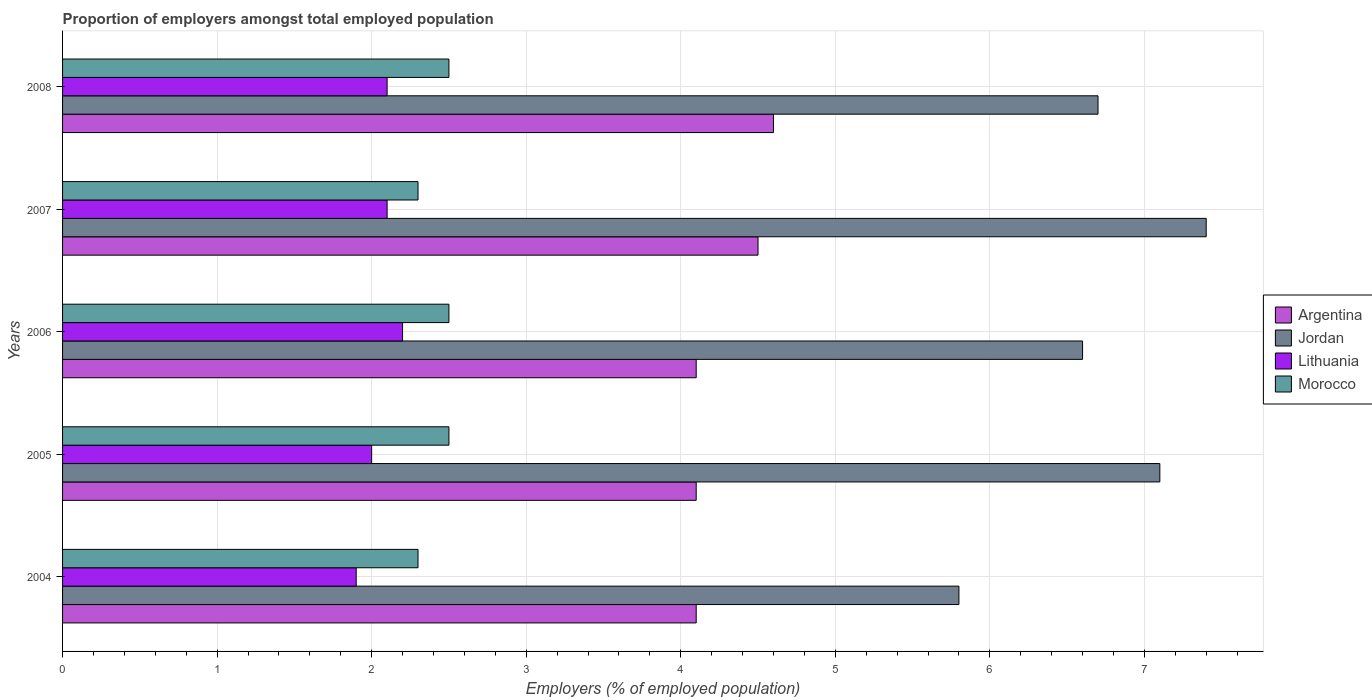How many groups of bars are there?
Offer a very short reply. 5. Are the number of bars on each tick of the Y-axis equal?
Provide a succinct answer. Yes. How many bars are there on the 2nd tick from the top?
Provide a short and direct response. 4. How many bars are there on the 2nd tick from the bottom?
Keep it short and to the point. 4. What is the label of the 2nd group of bars from the top?
Your response must be concise. 2007. In how many cases, is the number of bars for a given year not equal to the number of legend labels?
Offer a very short reply. 0. What is the proportion of employers in Lithuania in 2004?
Make the answer very short. 1.9. Across all years, what is the maximum proportion of employers in Lithuania?
Keep it short and to the point. 2.2. Across all years, what is the minimum proportion of employers in Jordan?
Give a very brief answer. 5.8. In which year was the proportion of employers in Argentina maximum?
Ensure brevity in your answer.  2008. In which year was the proportion of employers in Jordan minimum?
Make the answer very short. 2004. What is the total proportion of employers in Jordan in the graph?
Provide a short and direct response. 33.6. What is the difference between the proportion of employers in Morocco in 2007 and that in 2008?
Your answer should be very brief. -0.2. What is the difference between the proportion of employers in Argentina in 2006 and the proportion of employers in Morocco in 2005?
Provide a short and direct response. 1.6. What is the average proportion of employers in Jordan per year?
Your answer should be very brief. 6.72. In the year 2008, what is the difference between the proportion of employers in Lithuania and proportion of employers in Morocco?
Offer a terse response. -0.4. What is the ratio of the proportion of employers in Morocco in 2004 to that in 2005?
Your answer should be very brief. 0.92. Is the proportion of employers in Lithuania in 2004 less than that in 2008?
Make the answer very short. Yes. Is the difference between the proportion of employers in Lithuania in 2006 and 2008 greater than the difference between the proportion of employers in Morocco in 2006 and 2008?
Provide a short and direct response. Yes. What is the difference between the highest and the second highest proportion of employers in Jordan?
Provide a succinct answer. 0.3. What is the difference between the highest and the lowest proportion of employers in Jordan?
Offer a very short reply. 1.6. Is the sum of the proportion of employers in Jordan in 2004 and 2005 greater than the maximum proportion of employers in Argentina across all years?
Make the answer very short. Yes. What does the 3rd bar from the top in 2006 represents?
Make the answer very short. Jordan. What does the 2nd bar from the bottom in 2004 represents?
Make the answer very short. Jordan. Is it the case that in every year, the sum of the proportion of employers in Lithuania and proportion of employers in Jordan is greater than the proportion of employers in Morocco?
Your response must be concise. Yes. How many bars are there?
Keep it short and to the point. 20. How many years are there in the graph?
Ensure brevity in your answer.  5. Are the values on the major ticks of X-axis written in scientific E-notation?
Your answer should be very brief. No. Does the graph contain grids?
Your answer should be compact. Yes. How are the legend labels stacked?
Provide a succinct answer. Vertical. What is the title of the graph?
Your answer should be compact. Proportion of employers amongst total employed population. Does "Italy" appear as one of the legend labels in the graph?
Ensure brevity in your answer.  No. What is the label or title of the X-axis?
Your response must be concise. Employers (% of employed population). What is the Employers (% of employed population) of Argentina in 2004?
Ensure brevity in your answer.  4.1. What is the Employers (% of employed population) of Jordan in 2004?
Your response must be concise. 5.8. What is the Employers (% of employed population) in Lithuania in 2004?
Make the answer very short. 1.9. What is the Employers (% of employed population) in Morocco in 2004?
Provide a short and direct response. 2.3. What is the Employers (% of employed population) of Argentina in 2005?
Your answer should be very brief. 4.1. What is the Employers (% of employed population) of Jordan in 2005?
Your answer should be very brief. 7.1. What is the Employers (% of employed population) in Argentina in 2006?
Your response must be concise. 4.1. What is the Employers (% of employed population) of Jordan in 2006?
Ensure brevity in your answer.  6.6. What is the Employers (% of employed population) of Lithuania in 2006?
Ensure brevity in your answer.  2.2. What is the Employers (% of employed population) of Morocco in 2006?
Your response must be concise. 2.5. What is the Employers (% of employed population) in Jordan in 2007?
Offer a terse response. 7.4. What is the Employers (% of employed population) in Lithuania in 2007?
Give a very brief answer. 2.1. What is the Employers (% of employed population) in Morocco in 2007?
Make the answer very short. 2.3. What is the Employers (% of employed population) in Argentina in 2008?
Make the answer very short. 4.6. What is the Employers (% of employed population) of Jordan in 2008?
Your response must be concise. 6.7. What is the Employers (% of employed population) in Lithuania in 2008?
Ensure brevity in your answer.  2.1. What is the Employers (% of employed population) of Morocco in 2008?
Make the answer very short. 2.5. Across all years, what is the maximum Employers (% of employed population) of Argentina?
Provide a short and direct response. 4.6. Across all years, what is the maximum Employers (% of employed population) of Jordan?
Keep it short and to the point. 7.4. Across all years, what is the maximum Employers (% of employed population) in Lithuania?
Keep it short and to the point. 2.2. Across all years, what is the maximum Employers (% of employed population) in Morocco?
Your response must be concise. 2.5. Across all years, what is the minimum Employers (% of employed population) of Argentina?
Your answer should be very brief. 4.1. Across all years, what is the minimum Employers (% of employed population) of Jordan?
Offer a very short reply. 5.8. Across all years, what is the minimum Employers (% of employed population) in Lithuania?
Ensure brevity in your answer.  1.9. Across all years, what is the minimum Employers (% of employed population) of Morocco?
Provide a succinct answer. 2.3. What is the total Employers (% of employed population) in Argentina in the graph?
Your answer should be compact. 21.4. What is the total Employers (% of employed population) of Jordan in the graph?
Make the answer very short. 33.6. What is the total Employers (% of employed population) of Lithuania in the graph?
Offer a very short reply. 10.3. What is the total Employers (% of employed population) of Morocco in the graph?
Your answer should be compact. 12.1. What is the difference between the Employers (% of employed population) of Argentina in 2004 and that in 2005?
Your answer should be very brief. 0. What is the difference between the Employers (% of employed population) of Argentina in 2004 and that in 2006?
Make the answer very short. 0. What is the difference between the Employers (% of employed population) of Jordan in 2004 and that in 2006?
Make the answer very short. -0.8. What is the difference between the Employers (% of employed population) in Lithuania in 2004 and that in 2006?
Your answer should be very brief. -0.3. What is the difference between the Employers (% of employed population) of Morocco in 2004 and that in 2006?
Give a very brief answer. -0.2. What is the difference between the Employers (% of employed population) of Argentina in 2004 and that in 2007?
Ensure brevity in your answer.  -0.4. What is the difference between the Employers (% of employed population) of Lithuania in 2004 and that in 2007?
Your answer should be very brief. -0.2. What is the difference between the Employers (% of employed population) in Morocco in 2004 and that in 2007?
Your answer should be compact. 0. What is the difference between the Employers (% of employed population) of Argentina in 2005 and that in 2006?
Ensure brevity in your answer.  0. What is the difference between the Employers (% of employed population) in Jordan in 2005 and that in 2006?
Make the answer very short. 0.5. What is the difference between the Employers (% of employed population) of Argentina in 2005 and that in 2007?
Your answer should be compact. -0.4. What is the difference between the Employers (% of employed population) in Lithuania in 2005 and that in 2007?
Ensure brevity in your answer.  -0.1. What is the difference between the Employers (% of employed population) in Morocco in 2005 and that in 2007?
Your answer should be very brief. 0.2. What is the difference between the Employers (% of employed population) of Lithuania in 2005 and that in 2008?
Provide a short and direct response. -0.1. What is the difference between the Employers (% of employed population) of Morocco in 2005 and that in 2008?
Your answer should be very brief. 0. What is the difference between the Employers (% of employed population) of Argentina in 2006 and that in 2007?
Offer a very short reply. -0.4. What is the difference between the Employers (% of employed population) of Argentina in 2006 and that in 2008?
Provide a short and direct response. -0.5. What is the difference between the Employers (% of employed population) of Jordan in 2006 and that in 2008?
Keep it short and to the point. -0.1. What is the difference between the Employers (% of employed population) in Lithuania in 2006 and that in 2008?
Offer a terse response. 0.1. What is the difference between the Employers (% of employed population) in Morocco in 2006 and that in 2008?
Ensure brevity in your answer.  0. What is the difference between the Employers (% of employed population) of Lithuania in 2007 and that in 2008?
Provide a succinct answer. 0. What is the difference between the Employers (% of employed population) of Morocco in 2007 and that in 2008?
Keep it short and to the point. -0.2. What is the difference between the Employers (% of employed population) of Argentina in 2004 and the Employers (% of employed population) of Jordan in 2005?
Make the answer very short. -3. What is the difference between the Employers (% of employed population) of Jordan in 2004 and the Employers (% of employed population) of Lithuania in 2005?
Offer a terse response. 3.8. What is the difference between the Employers (% of employed population) of Jordan in 2004 and the Employers (% of employed population) of Morocco in 2005?
Offer a very short reply. 3.3. What is the difference between the Employers (% of employed population) of Argentina in 2004 and the Employers (% of employed population) of Lithuania in 2006?
Keep it short and to the point. 1.9. What is the difference between the Employers (% of employed population) in Argentina in 2004 and the Employers (% of employed population) in Morocco in 2006?
Keep it short and to the point. 1.6. What is the difference between the Employers (% of employed population) of Jordan in 2004 and the Employers (% of employed population) of Lithuania in 2006?
Keep it short and to the point. 3.6. What is the difference between the Employers (% of employed population) in Jordan in 2004 and the Employers (% of employed population) in Morocco in 2006?
Offer a very short reply. 3.3. What is the difference between the Employers (% of employed population) in Argentina in 2004 and the Employers (% of employed population) in Jordan in 2007?
Make the answer very short. -3.3. What is the difference between the Employers (% of employed population) of Argentina in 2004 and the Employers (% of employed population) of Lithuania in 2007?
Make the answer very short. 2. What is the difference between the Employers (% of employed population) of Lithuania in 2004 and the Employers (% of employed population) of Morocco in 2007?
Ensure brevity in your answer.  -0.4. What is the difference between the Employers (% of employed population) of Argentina in 2004 and the Employers (% of employed population) of Jordan in 2008?
Offer a very short reply. -2.6. What is the difference between the Employers (% of employed population) in Argentina in 2004 and the Employers (% of employed population) in Lithuania in 2008?
Provide a short and direct response. 2. What is the difference between the Employers (% of employed population) of Argentina in 2004 and the Employers (% of employed population) of Morocco in 2008?
Your response must be concise. 1.6. What is the difference between the Employers (% of employed population) of Jordan in 2004 and the Employers (% of employed population) of Morocco in 2008?
Your answer should be very brief. 3.3. What is the difference between the Employers (% of employed population) of Lithuania in 2004 and the Employers (% of employed population) of Morocco in 2008?
Your answer should be very brief. -0.6. What is the difference between the Employers (% of employed population) in Argentina in 2005 and the Employers (% of employed population) in Morocco in 2006?
Keep it short and to the point. 1.6. What is the difference between the Employers (% of employed population) in Jordan in 2005 and the Employers (% of employed population) in Morocco in 2006?
Provide a succinct answer. 4.6. What is the difference between the Employers (% of employed population) of Lithuania in 2005 and the Employers (% of employed population) of Morocco in 2006?
Provide a succinct answer. -0.5. What is the difference between the Employers (% of employed population) in Argentina in 2005 and the Employers (% of employed population) in Jordan in 2007?
Provide a succinct answer. -3.3. What is the difference between the Employers (% of employed population) in Argentina in 2005 and the Employers (% of employed population) in Morocco in 2007?
Make the answer very short. 1.8. What is the difference between the Employers (% of employed population) in Lithuania in 2005 and the Employers (% of employed population) in Morocco in 2007?
Keep it short and to the point. -0.3. What is the difference between the Employers (% of employed population) of Argentina in 2005 and the Employers (% of employed population) of Jordan in 2008?
Keep it short and to the point. -2.6. What is the difference between the Employers (% of employed population) in Lithuania in 2005 and the Employers (% of employed population) in Morocco in 2008?
Keep it short and to the point. -0.5. What is the difference between the Employers (% of employed population) in Lithuania in 2006 and the Employers (% of employed population) in Morocco in 2007?
Ensure brevity in your answer.  -0.1. What is the difference between the Employers (% of employed population) in Argentina in 2006 and the Employers (% of employed population) in Jordan in 2008?
Ensure brevity in your answer.  -2.6. What is the difference between the Employers (% of employed population) of Argentina in 2006 and the Employers (% of employed population) of Morocco in 2008?
Keep it short and to the point. 1.6. What is the difference between the Employers (% of employed population) in Argentina in 2007 and the Employers (% of employed population) in Lithuania in 2008?
Your answer should be compact. 2.4. What is the difference between the Employers (% of employed population) of Jordan in 2007 and the Employers (% of employed population) of Morocco in 2008?
Your answer should be very brief. 4.9. What is the difference between the Employers (% of employed population) in Lithuania in 2007 and the Employers (% of employed population) in Morocco in 2008?
Ensure brevity in your answer.  -0.4. What is the average Employers (% of employed population) in Argentina per year?
Provide a succinct answer. 4.28. What is the average Employers (% of employed population) in Jordan per year?
Offer a very short reply. 6.72. What is the average Employers (% of employed population) in Lithuania per year?
Your answer should be very brief. 2.06. What is the average Employers (% of employed population) in Morocco per year?
Ensure brevity in your answer.  2.42. In the year 2004, what is the difference between the Employers (% of employed population) in Jordan and Employers (% of employed population) in Lithuania?
Ensure brevity in your answer.  3.9. In the year 2005, what is the difference between the Employers (% of employed population) in Argentina and Employers (% of employed population) in Jordan?
Ensure brevity in your answer.  -3. In the year 2005, what is the difference between the Employers (% of employed population) in Argentina and Employers (% of employed population) in Lithuania?
Offer a very short reply. 2.1. In the year 2005, what is the difference between the Employers (% of employed population) of Argentina and Employers (% of employed population) of Morocco?
Offer a very short reply. 1.6. In the year 2005, what is the difference between the Employers (% of employed population) in Jordan and Employers (% of employed population) in Lithuania?
Ensure brevity in your answer.  5.1. In the year 2005, what is the difference between the Employers (% of employed population) in Jordan and Employers (% of employed population) in Morocco?
Provide a short and direct response. 4.6. In the year 2006, what is the difference between the Employers (% of employed population) in Argentina and Employers (% of employed population) in Jordan?
Your answer should be compact. -2.5. In the year 2006, what is the difference between the Employers (% of employed population) in Argentina and Employers (% of employed population) in Morocco?
Offer a very short reply. 1.6. In the year 2006, what is the difference between the Employers (% of employed population) in Jordan and Employers (% of employed population) in Lithuania?
Offer a very short reply. 4.4. In the year 2006, what is the difference between the Employers (% of employed population) of Jordan and Employers (% of employed population) of Morocco?
Your answer should be very brief. 4.1. In the year 2006, what is the difference between the Employers (% of employed population) in Lithuania and Employers (% of employed population) in Morocco?
Offer a very short reply. -0.3. In the year 2007, what is the difference between the Employers (% of employed population) of Argentina and Employers (% of employed population) of Lithuania?
Offer a terse response. 2.4. In the year 2007, what is the difference between the Employers (% of employed population) in Lithuania and Employers (% of employed population) in Morocco?
Provide a succinct answer. -0.2. In the year 2008, what is the difference between the Employers (% of employed population) in Argentina and Employers (% of employed population) in Jordan?
Keep it short and to the point. -2.1. In the year 2008, what is the difference between the Employers (% of employed population) in Argentina and Employers (% of employed population) in Morocco?
Ensure brevity in your answer.  2.1. What is the ratio of the Employers (% of employed population) of Argentina in 2004 to that in 2005?
Provide a short and direct response. 1. What is the ratio of the Employers (% of employed population) in Jordan in 2004 to that in 2005?
Offer a very short reply. 0.82. What is the ratio of the Employers (% of employed population) of Lithuania in 2004 to that in 2005?
Your answer should be compact. 0.95. What is the ratio of the Employers (% of employed population) in Argentina in 2004 to that in 2006?
Your answer should be compact. 1. What is the ratio of the Employers (% of employed population) in Jordan in 2004 to that in 2006?
Keep it short and to the point. 0.88. What is the ratio of the Employers (% of employed population) of Lithuania in 2004 to that in 2006?
Your answer should be very brief. 0.86. What is the ratio of the Employers (% of employed population) in Argentina in 2004 to that in 2007?
Your response must be concise. 0.91. What is the ratio of the Employers (% of employed population) of Jordan in 2004 to that in 2007?
Offer a terse response. 0.78. What is the ratio of the Employers (% of employed population) in Lithuania in 2004 to that in 2007?
Provide a short and direct response. 0.9. What is the ratio of the Employers (% of employed population) in Argentina in 2004 to that in 2008?
Offer a very short reply. 0.89. What is the ratio of the Employers (% of employed population) of Jordan in 2004 to that in 2008?
Provide a succinct answer. 0.87. What is the ratio of the Employers (% of employed population) of Lithuania in 2004 to that in 2008?
Offer a terse response. 0.9. What is the ratio of the Employers (% of employed population) of Argentina in 2005 to that in 2006?
Keep it short and to the point. 1. What is the ratio of the Employers (% of employed population) in Jordan in 2005 to that in 2006?
Keep it short and to the point. 1.08. What is the ratio of the Employers (% of employed population) in Morocco in 2005 to that in 2006?
Your answer should be compact. 1. What is the ratio of the Employers (% of employed population) of Argentina in 2005 to that in 2007?
Give a very brief answer. 0.91. What is the ratio of the Employers (% of employed population) of Jordan in 2005 to that in 2007?
Provide a succinct answer. 0.96. What is the ratio of the Employers (% of employed population) in Lithuania in 2005 to that in 2007?
Offer a terse response. 0.95. What is the ratio of the Employers (% of employed population) in Morocco in 2005 to that in 2007?
Your response must be concise. 1.09. What is the ratio of the Employers (% of employed population) of Argentina in 2005 to that in 2008?
Offer a terse response. 0.89. What is the ratio of the Employers (% of employed population) of Jordan in 2005 to that in 2008?
Ensure brevity in your answer.  1.06. What is the ratio of the Employers (% of employed population) in Argentina in 2006 to that in 2007?
Keep it short and to the point. 0.91. What is the ratio of the Employers (% of employed population) of Jordan in 2006 to that in 2007?
Give a very brief answer. 0.89. What is the ratio of the Employers (% of employed population) of Lithuania in 2006 to that in 2007?
Provide a short and direct response. 1.05. What is the ratio of the Employers (% of employed population) of Morocco in 2006 to that in 2007?
Make the answer very short. 1.09. What is the ratio of the Employers (% of employed population) in Argentina in 2006 to that in 2008?
Your response must be concise. 0.89. What is the ratio of the Employers (% of employed population) of Jordan in 2006 to that in 2008?
Provide a succinct answer. 0.99. What is the ratio of the Employers (% of employed population) in Lithuania in 2006 to that in 2008?
Provide a succinct answer. 1.05. What is the ratio of the Employers (% of employed population) in Morocco in 2006 to that in 2008?
Keep it short and to the point. 1. What is the ratio of the Employers (% of employed population) of Argentina in 2007 to that in 2008?
Your response must be concise. 0.98. What is the ratio of the Employers (% of employed population) of Jordan in 2007 to that in 2008?
Offer a very short reply. 1.1. What is the ratio of the Employers (% of employed population) of Morocco in 2007 to that in 2008?
Your answer should be very brief. 0.92. What is the difference between the highest and the second highest Employers (% of employed population) of Jordan?
Your answer should be compact. 0.3. What is the difference between the highest and the second highest Employers (% of employed population) in Morocco?
Give a very brief answer. 0. 